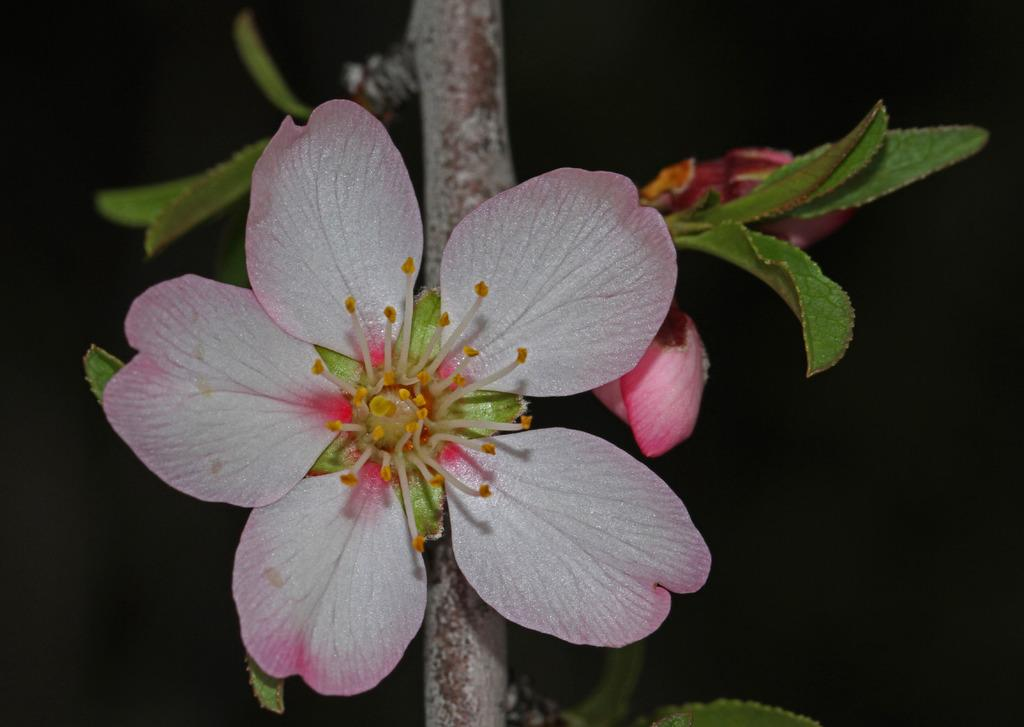What is the main subject of the image? There is a flower in the image. What color is the flower? The flower is pink in color. What can be seen behind the flower? There are leaves behind the flower. What type of circle is being used to rake the lunch in the image? There is no circle, rake, or lunch present in the image; it features a pink flower with leaves behind it. 